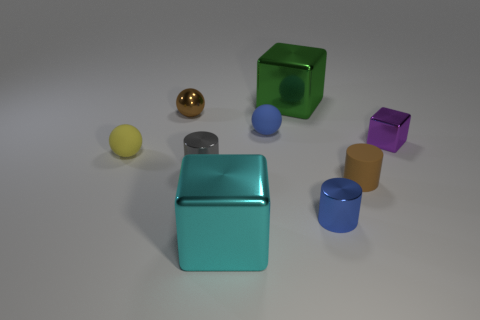There is a cube that is the same size as the gray cylinder; what is it made of?
Ensure brevity in your answer.  Metal. What number of tiny objects are either purple cubes or cyan cylinders?
Offer a very short reply. 1. Are any tiny blue cylinders visible?
Make the answer very short. Yes. There is a brown object that is the same material as the purple block; what size is it?
Give a very brief answer. Small. Do the cyan cube and the tiny gray object have the same material?
Keep it short and to the point. Yes. What number of other objects are the same material as the purple cube?
Provide a short and direct response. 5. What number of metal blocks are left of the purple cube and in front of the large green shiny thing?
Ensure brevity in your answer.  1. What color is the small metal block?
Your answer should be compact. Purple. What is the material of the small thing that is the same shape as the big green object?
Your answer should be compact. Metal. Are there any other things that have the same material as the purple cube?
Your answer should be very brief. Yes. 